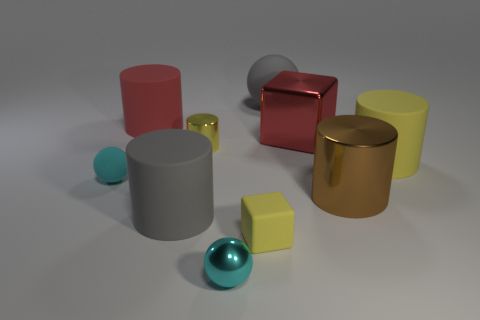What is the material of the brown object that is the same shape as the large red rubber object?
Make the answer very short. Metal. There is a tiny cyan sphere on the right side of the yellow cylinder left of the big yellow cylinder; are there any small rubber things behind it?
Offer a very short reply. Yes. How many other things are there of the same color as the large metallic block?
Give a very brief answer. 1. What number of big shiny objects are both in front of the large yellow rubber object and behind the small matte sphere?
Ensure brevity in your answer.  0. What is the shape of the red rubber object?
Give a very brief answer. Cylinder. How many other things are made of the same material as the gray cylinder?
Your response must be concise. 5. What color is the matte ball to the right of the tiny rubber object that is right of the large gray rubber object in front of the gray sphere?
Offer a terse response. Gray. There is a yellow cylinder that is the same size as the gray rubber ball; what material is it?
Offer a terse response. Rubber. How many objects are rubber things on the left side of the cyan metallic ball or large red things?
Offer a terse response. 4. Are there any brown metallic objects?
Ensure brevity in your answer.  Yes. 